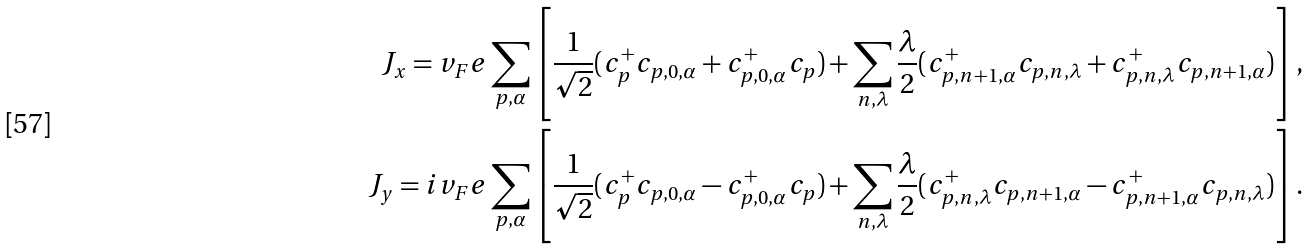<formula> <loc_0><loc_0><loc_500><loc_500>J _ { x } = v _ { F } e \sum _ { p , \alpha } \left [ \frac { 1 } { \sqrt { 2 } } ( c ^ { + } _ { p } c _ { p , 0 , \alpha } + c ^ { + } _ { p , 0 , \alpha } c _ { p } ) + \sum _ { n , \lambda } \frac { \lambda } { 2 } ( c ^ { + } _ { p , n + 1 , \alpha } c _ { p , n , \lambda } + c ^ { + } _ { p , n , \lambda } c _ { p , n + 1 , \alpha } ) \right ] , \\ J _ { y } = i v _ { F } e \sum _ { p , \alpha } \left [ \frac { 1 } { \sqrt { 2 } } ( c ^ { + } _ { p } c _ { p , 0 , \alpha } - c ^ { + } _ { p , 0 , \alpha } c _ { p } ) + \sum _ { n , \lambda } \frac { \lambda } { 2 } ( c ^ { + } _ { p , n , \lambda } c _ { p , n + 1 , \alpha } - c ^ { + } _ { p , n + 1 , \alpha } c _ { p , n , \lambda } ) \right ] .</formula> 